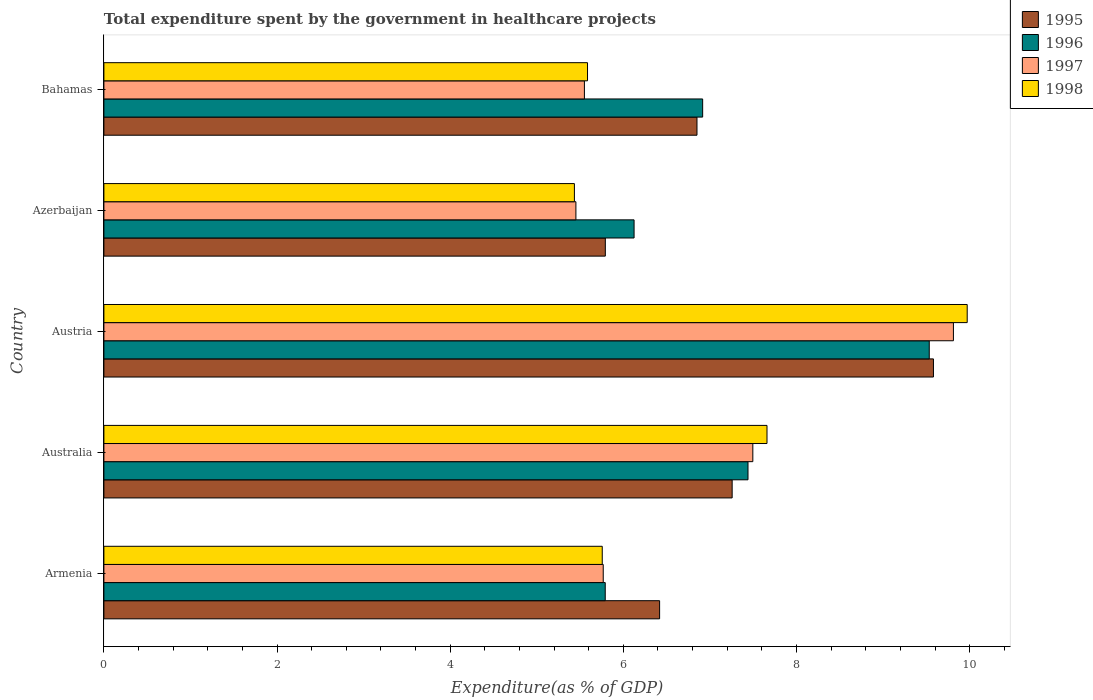Are the number of bars per tick equal to the number of legend labels?
Your response must be concise. Yes. How many bars are there on the 2nd tick from the bottom?
Your response must be concise. 4. What is the label of the 4th group of bars from the top?
Ensure brevity in your answer.  Australia. What is the total expenditure spent by the government in healthcare projects in 1998 in Azerbaijan?
Offer a very short reply. 5.43. Across all countries, what is the maximum total expenditure spent by the government in healthcare projects in 1997?
Offer a very short reply. 9.81. Across all countries, what is the minimum total expenditure spent by the government in healthcare projects in 1997?
Keep it short and to the point. 5.45. In which country was the total expenditure spent by the government in healthcare projects in 1997 maximum?
Your answer should be very brief. Austria. In which country was the total expenditure spent by the government in healthcare projects in 1998 minimum?
Keep it short and to the point. Azerbaijan. What is the total total expenditure spent by the government in healthcare projects in 1996 in the graph?
Ensure brevity in your answer.  35.8. What is the difference between the total expenditure spent by the government in healthcare projects in 1997 in Austria and that in Bahamas?
Your response must be concise. 4.26. What is the difference between the total expenditure spent by the government in healthcare projects in 1996 in Australia and the total expenditure spent by the government in healthcare projects in 1998 in Armenia?
Make the answer very short. 1.68. What is the average total expenditure spent by the government in healthcare projects in 1998 per country?
Your response must be concise. 6.88. What is the difference between the total expenditure spent by the government in healthcare projects in 1998 and total expenditure spent by the government in healthcare projects in 1995 in Austria?
Keep it short and to the point. 0.39. What is the ratio of the total expenditure spent by the government in healthcare projects in 1996 in Austria to that in Bahamas?
Make the answer very short. 1.38. What is the difference between the highest and the second highest total expenditure spent by the government in healthcare projects in 1995?
Ensure brevity in your answer.  2.33. What is the difference between the highest and the lowest total expenditure spent by the government in healthcare projects in 1996?
Offer a terse response. 3.74. In how many countries, is the total expenditure spent by the government in healthcare projects in 1996 greater than the average total expenditure spent by the government in healthcare projects in 1996 taken over all countries?
Ensure brevity in your answer.  2. Is the sum of the total expenditure spent by the government in healthcare projects in 1997 in Armenia and Bahamas greater than the maximum total expenditure spent by the government in healthcare projects in 1995 across all countries?
Your answer should be very brief. Yes. What does the 4th bar from the top in Australia represents?
Your answer should be compact. 1995. Is it the case that in every country, the sum of the total expenditure spent by the government in healthcare projects in 1995 and total expenditure spent by the government in healthcare projects in 1996 is greater than the total expenditure spent by the government in healthcare projects in 1997?
Your answer should be compact. Yes. How many bars are there?
Offer a very short reply. 20. Are the values on the major ticks of X-axis written in scientific E-notation?
Your answer should be compact. No. Does the graph contain any zero values?
Give a very brief answer. No. Does the graph contain grids?
Provide a succinct answer. No. What is the title of the graph?
Your answer should be very brief. Total expenditure spent by the government in healthcare projects. Does "1977" appear as one of the legend labels in the graph?
Ensure brevity in your answer.  No. What is the label or title of the X-axis?
Give a very brief answer. Expenditure(as % of GDP). What is the label or title of the Y-axis?
Make the answer very short. Country. What is the Expenditure(as % of GDP) in 1995 in Armenia?
Offer a very short reply. 6.42. What is the Expenditure(as % of GDP) in 1996 in Armenia?
Your answer should be compact. 5.79. What is the Expenditure(as % of GDP) of 1997 in Armenia?
Your answer should be compact. 5.77. What is the Expenditure(as % of GDP) in 1998 in Armenia?
Give a very brief answer. 5.76. What is the Expenditure(as % of GDP) of 1995 in Australia?
Offer a terse response. 7.26. What is the Expenditure(as % of GDP) of 1996 in Australia?
Provide a succinct answer. 7.44. What is the Expenditure(as % of GDP) in 1997 in Australia?
Offer a very short reply. 7.5. What is the Expenditure(as % of GDP) in 1998 in Australia?
Offer a very short reply. 7.66. What is the Expenditure(as % of GDP) in 1995 in Austria?
Keep it short and to the point. 9.58. What is the Expenditure(as % of GDP) of 1996 in Austria?
Give a very brief answer. 9.53. What is the Expenditure(as % of GDP) in 1997 in Austria?
Offer a very short reply. 9.81. What is the Expenditure(as % of GDP) of 1998 in Austria?
Your answer should be compact. 9.97. What is the Expenditure(as % of GDP) of 1995 in Azerbaijan?
Offer a terse response. 5.79. What is the Expenditure(as % of GDP) in 1996 in Azerbaijan?
Offer a very short reply. 6.12. What is the Expenditure(as % of GDP) of 1997 in Azerbaijan?
Your response must be concise. 5.45. What is the Expenditure(as % of GDP) of 1998 in Azerbaijan?
Ensure brevity in your answer.  5.43. What is the Expenditure(as % of GDP) in 1995 in Bahamas?
Offer a very short reply. 6.85. What is the Expenditure(as % of GDP) in 1996 in Bahamas?
Ensure brevity in your answer.  6.92. What is the Expenditure(as % of GDP) in 1997 in Bahamas?
Provide a succinct answer. 5.55. What is the Expenditure(as % of GDP) in 1998 in Bahamas?
Keep it short and to the point. 5.59. Across all countries, what is the maximum Expenditure(as % of GDP) in 1995?
Offer a very short reply. 9.58. Across all countries, what is the maximum Expenditure(as % of GDP) of 1996?
Provide a short and direct response. 9.53. Across all countries, what is the maximum Expenditure(as % of GDP) in 1997?
Provide a succinct answer. 9.81. Across all countries, what is the maximum Expenditure(as % of GDP) in 1998?
Your response must be concise. 9.97. Across all countries, what is the minimum Expenditure(as % of GDP) of 1995?
Provide a succinct answer. 5.79. Across all countries, what is the minimum Expenditure(as % of GDP) of 1996?
Make the answer very short. 5.79. Across all countries, what is the minimum Expenditure(as % of GDP) of 1997?
Keep it short and to the point. 5.45. Across all countries, what is the minimum Expenditure(as % of GDP) in 1998?
Provide a succinct answer. 5.43. What is the total Expenditure(as % of GDP) in 1995 in the graph?
Your answer should be very brief. 35.9. What is the total Expenditure(as % of GDP) in 1996 in the graph?
Keep it short and to the point. 35.8. What is the total Expenditure(as % of GDP) in 1997 in the graph?
Keep it short and to the point. 34.08. What is the total Expenditure(as % of GDP) in 1998 in the graph?
Your answer should be very brief. 34.41. What is the difference between the Expenditure(as % of GDP) of 1995 in Armenia and that in Australia?
Your answer should be compact. -0.84. What is the difference between the Expenditure(as % of GDP) in 1996 in Armenia and that in Australia?
Your answer should be compact. -1.65. What is the difference between the Expenditure(as % of GDP) in 1997 in Armenia and that in Australia?
Your response must be concise. -1.73. What is the difference between the Expenditure(as % of GDP) of 1998 in Armenia and that in Australia?
Ensure brevity in your answer.  -1.9. What is the difference between the Expenditure(as % of GDP) of 1995 in Armenia and that in Austria?
Keep it short and to the point. -3.16. What is the difference between the Expenditure(as % of GDP) of 1996 in Armenia and that in Austria?
Provide a short and direct response. -3.74. What is the difference between the Expenditure(as % of GDP) in 1997 in Armenia and that in Austria?
Give a very brief answer. -4.04. What is the difference between the Expenditure(as % of GDP) in 1998 in Armenia and that in Austria?
Offer a terse response. -4.22. What is the difference between the Expenditure(as % of GDP) in 1995 in Armenia and that in Azerbaijan?
Make the answer very short. 0.63. What is the difference between the Expenditure(as % of GDP) in 1996 in Armenia and that in Azerbaijan?
Make the answer very short. -0.33. What is the difference between the Expenditure(as % of GDP) in 1997 in Armenia and that in Azerbaijan?
Your response must be concise. 0.32. What is the difference between the Expenditure(as % of GDP) in 1998 in Armenia and that in Azerbaijan?
Offer a terse response. 0.32. What is the difference between the Expenditure(as % of GDP) of 1995 in Armenia and that in Bahamas?
Your response must be concise. -0.43. What is the difference between the Expenditure(as % of GDP) of 1996 in Armenia and that in Bahamas?
Your answer should be compact. -1.13. What is the difference between the Expenditure(as % of GDP) of 1997 in Armenia and that in Bahamas?
Keep it short and to the point. 0.22. What is the difference between the Expenditure(as % of GDP) of 1998 in Armenia and that in Bahamas?
Provide a short and direct response. 0.17. What is the difference between the Expenditure(as % of GDP) of 1995 in Australia and that in Austria?
Provide a short and direct response. -2.33. What is the difference between the Expenditure(as % of GDP) in 1996 in Australia and that in Austria?
Ensure brevity in your answer.  -2.09. What is the difference between the Expenditure(as % of GDP) in 1997 in Australia and that in Austria?
Provide a succinct answer. -2.32. What is the difference between the Expenditure(as % of GDP) of 1998 in Australia and that in Austria?
Your answer should be compact. -2.31. What is the difference between the Expenditure(as % of GDP) of 1995 in Australia and that in Azerbaijan?
Your response must be concise. 1.46. What is the difference between the Expenditure(as % of GDP) of 1996 in Australia and that in Azerbaijan?
Offer a very short reply. 1.32. What is the difference between the Expenditure(as % of GDP) in 1997 in Australia and that in Azerbaijan?
Offer a very short reply. 2.04. What is the difference between the Expenditure(as % of GDP) of 1998 in Australia and that in Azerbaijan?
Ensure brevity in your answer.  2.22. What is the difference between the Expenditure(as % of GDP) in 1995 in Australia and that in Bahamas?
Give a very brief answer. 0.41. What is the difference between the Expenditure(as % of GDP) of 1996 in Australia and that in Bahamas?
Your answer should be very brief. 0.52. What is the difference between the Expenditure(as % of GDP) in 1997 in Australia and that in Bahamas?
Your answer should be very brief. 1.95. What is the difference between the Expenditure(as % of GDP) in 1998 in Australia and that in Bahamas?
Offer a terse response. 2.07. What is the difference between the Expenditure(as % of GDP) in 1995 in Austria and that in Azerbaijan?
Keep it short and to the point. 3.79. What is the difference between the Expenditure(as % of GDP) of 1996 in Austria and that in Azerbaijan?
Offer a very short reply. 3.41. What is the difference between the Expenditure(as % of GDP) of 1997 in Austria and that in Azerbaijan?
Your response must be concise. 4.36. What is the difference between the Expenditure(as % of GDP) of 1998 in Austria and that in Azerbaijan?
Your answer should be compact. 4.54. What is the difference between the Expenditure(as % of GDP) in 1995 in Austria and that in Bahamas?
Offer a terse response. 2.73. What is the difference between the Expenditure(as % of GDP) of 1996 in Austria and that in Bahamas?
Provide a short and direct response. 2.62. What is the difference between the Expenditure(as % of GDP) in 1997 in Austria and that in Bahamas?
Your answer should be compact. 4.26. What is the difference between the Expenditure(as % of GDP) in 1998 in Austria and that in Bahamas?
Ensure brevity in your answer.  4.39. What is the difference between the Expenditure(as % of GDP) in 1995 in Azerbaijan and that in Bahamas?
Offer a very short reply. -1.06. What is the difference between the Expenditure(as % of GDP) of 1996 in Azerbaijan and that in Bahamas?
Your answer should be very brief. -0.79. What is the difference between the Expenditure(as % of GDP) in 1997 in Azerbaijan and that in Bahamas?
Your answer should be compact. -0.1. What is the difference between the Expenditure(as % of GDP) in 1998 in Azerbaijan and that in Bahamas?
Ensure brevity in your answer.  -0.15. What is the difference between the Expenditure(as % of GDP) in 1995 in Armenia and the Expenditure(as % of GDP) in 1996 in Australia?
Your answer should be compact. -1.02. What is the difference between the Expenditure(as % of GDP) in 1995 in Armenia and the Expenditure(as % of GDP) in 1997 in Australia?
Your answer should be compact. -1.08. What is the difference between the Expenditure(as % of GDP) in 1995 in Armenia and the Expenditure(as % of GDP) in 1998 in Australia?
Provide a succinct answer. -1.24. What is the difference between the Expenditure(as % of GDP) in 1996 in Armenia and the Expenditure(as % of GDP) in 1997 in Australia?
Make the answer very short. -1.7. What is the difference between the Expenditure(as % of GDP) in 1996 in Armenia and the Expenditure(as % of GDP) in 1998 in Australia?
Offer a terse response. -1.87. What is the difference between the Expenditure(as % of GDP) in 1997 in Armenia and the Expenditure(as % of GDP) in 1998 in Australia?
Ensure brevity in your answer.  -1.89. What is the difference between the Expenditure(as % of GDP) of 1995 in Armenia and the Expenditure(as % of GDP) of 1996 in Austria?
Offer a terse response. -3.11. What is the difference between the Expenditure(as % of GDP) in 1995 in Armenia and the Expenditure(as % of GDP) in 1997 in Austria?
Offer a terse response. -3.39. What is the difference between the Expenditure(as % of GDP) of 1995 in Armenia and the Expenditure(as % of GDP) of 1998 in Austria?
Provide a short and direct response. -3.55. What is the difference between the Expenditure(as % of GDP) in 1996 in Armenia and the Expenditure(as % of GDP) in 1997 in Austria?
Your answer should be compact. -4.02. What is the difference between the Expenditure(as % of GDP) in 1996 in Armenia and the Expenditure(as % of GDP) in 1998 in Austria?
Make the answer very short. -4.18. What is the difference between the Expenditure(as % of GDP) in 1997 in Armenia and the Expenditure(as % of GDP) in 1998 in Austria?
Your answer should be compact. -4.2. What is the difference between the Expenditure(as % of GDP) in 1995 in Armenia and the Expenditure(as % of GDP) in 1996 in Azerbaijan?
Make the answer very short. 0.29. What is the difference between the Expenditure(as % of GDP) of 1995 in Armenia and the Expenditure(as % of GDP) of 1997 in Azerbaijan?
Offer a very short reply. 0.97. What is the difference between the Expenditure(as % of GDP) in 1995 in Armenia and the Expenditure(as % of GDP) in 1998 in Azerbaijan?
Provide a short and direct response. 0.98. What is the difference between the Expenditure(as % of GDP) in 1996 in Armenia and the Expenditure(as % of GDP) in 1997 in Azerbaijan?
Give a very brief answer. 0.34. What is the difference between the Expenditure(as % of GDP) in 1996 in Armenia and the Expenditure(as % of GDP) in 1998 in Azerbaijan?
Ensure brevity in your answer.  0.36. What is the difference between the Expenditure(as % of GDP) of 1997 in Armenia and the Expenditure(as % of GDP) of 1998 in Azerbaijan?
Offer a very short reply. 0.33. What is the difference between the Expenditure(as % of GDP) in 1995 in Armenia and the Expenditure(as % of GDP) in 1996 in Bahamas?
Offer a very short reply. -0.5. What is the difference between the Expenditure(as % of GDP) in 1995 in Armenia and the Expenditure(as % of GDP) in 1997 in Bahamas?
Provide a succinct answer. 0.87. What is the difference between the Expenditure(as % of GDP) in 1995 in Armenia and the Expenditure(as % of GDP) in 1998 in Bahamas?
Your answer should be compact. 0.83. What is the difference between the Expenditure(as % of GDP) in 1996 in Armenia and the Expenditure(as % of GDP) in 1997 in Bahamas?
Provide a succinct answer. 0.24. What is the difference between the Expenditure(as % of GDP) of 1996 in Armenia and the Expenditure(as % of GDP) of 1998 in Bahamas?
Offer a terse response. 0.2. What is the difference between the Expenditure(as % of GDP) in 1997 in Armenia and the Expenditure(as % of GDP) in 1998 in Bahamas?
Make the answer very short. 0.18. What is the difference between the Expenditure(as % of GDP) of 1995 in Australia and the Expenditure(as % of GDP) of 1996 in Austria?
Your answer should be very brief. -2.28. What is the difference between the Expenditure(as % of GDP) of 1995 in Australia and the Expenditure(as % of GDP) of 1997 in Austria?
Offer a very short reply. -2.56. What is the difference between the Expenditure(as % of GDP) of 1995 in Australia and the Expenditure(as % of GDP) of 1998 in Austria?
Your answer should be compact. -2.71. What is the difference between the Expenditure(as % of GDP) of 1996 in Australia and the Expenditure(as % of GDP) of 1997 in Austria?
Provide a succinct answer. -2.37. What is the difference between the Expenditure(as % of GDP) of 1996 in Australia and the Expenditure(as % of GDP) of 1998 in Austria?
Keep it short and to the point. -2.53. What is the difference between the Expenditure(as % of GDP) in 1997 in Australia and the Expenditure(as % of GDP) in 1998 in Austria?
Offer a terse response. -2.48. What is the difference between the Expenditure(as % of GDP) in 1995 in Australia and the Expenditure(as % of GDP) in 1996 in Azerbaijan?
Make the answer very short. 1.13. What is the difference between the Expenditure(as % of GDP) of 1995 in Australia and the Expenditure(as % of GDP) of 1997 in Azerbaijan?
Your response must be concise. 1.8. What is the difference between the Expenditure(as % of GDP) of 1995 in Australia and the Expenditure(as % of GDP) of 1998 in Azerbaijan?
Provide a succinct answer. 1.82. What is the difference between the Expenditure(as % of GDP) in 1996 in Australia and the Expenditure(as % of GDP) in 1997 in Azerbaijan?
Your answer should be very brief. 1.99. What is the difference between the Expenditure(as % of GDP) of 1996 in Australia and the Expenditure(as % of GDP) of 1998 in Azerbaijan?
Provide a succinct answer. 2.01. What is the difference between the Expenditure(as % of GDP) in 1997 in Australia and the Expenditure(as % of GDP) in 1998 in Azerbaijan?
Provide a short and direct response. 2.06. What is the difference between the Expenditure(as % of GDP) of 1995 in Australia and the Expenditure(as % of GDP) of 1996 in Bahamas?
Provide a short and direct response. 0.34. What is the difference between the Expenditure(as % of GDP) in 1995 in Australia and the Expenditure(as % of GDP) in 1997 in Bahamas?
Keep it short and to the point. 1.71. What is the difference between the Expenditure(as % of GDP) of 1995 in Australia and the Expenditure(as % of GDP) of 1998 in Bahamas?
Provide a short and direct response. 1.67. What is the difference between the Expenditure(as % of GDP) of 1996 in Australia and the Expenditure(as % of GDP) of 1997 in Bahamas?
Make the answer very short. 1.89. What is the difference between the Expenditure(as % of GDP) of 1996 in Australia and the Expenditure(as % of GDP) of 1998 in Bahamas?
Your answer should be very brief. 1.85. What is the difference between the Expenditure(as % of GDP) of 1997 in Australia and the Expenditure(as % of GDP) of 1998 in Bahamas?
Your answer should be compact. 1.91. What is the difference between the Expenditure(as % of GDP) of 1995 in Austria and the Expenditure(as % of GDP) of 1996 in Azerbaijan?
Provide a succinct answer. 3.46. What is the difference between the Expenditure(as % of GDP) in 1995 in Austria and the Expenditure(as % of GDP) in 1997 in Azerbaijan?
Your response must be concise. 4.13. What is the difference between the Expenditure(as % of GDP) in 1995 in Austria and the Expenditure(as % of GDP) in 1998 in Azerbaijan?
Provide a short and direct response. 4.15. What is the difference between the Expenditure(as % of GDP) of 1996 in Austria and the Expenditure(as % of GDP) of 1997 in Azerbaijan?
Ensure brevity in your answer.  4.08. What is the difference between the Expenditure(as % of GDP) in 1996 in Austria and the Expenditure(as % of GDP) in 1998 in Azerbaijan?
Your response must be concise. 4.1. What is the difference between the Expenditure(as % of GDP) of 1997 in Austria and the Expenditure(as % of GDP) of 1998 in Azerbaijan?
Provide a short and direct response. 4.38. What is the difference between the Expenditure(as % of GDP) in 1995 in Austria and the Expenditure(as % of GDP) in 1996 in Bahamas?
Offer a terse response. 2.67. What is the difference between the Expenditure(as % of GDP) of 1995 in Austria and the Expenditure(as % of GDP) of 1997 in Bahamas?
Offer a very short reply. 4.03. What is the difference between the Expenditure(as % of GDP) of 1995 in Austria and the Expenditure(as % of GDP) of 1998 in Bahamas?
Provide a short and direct response. 4. What is the difference between the Expenditure(as % of GDP) of 1996 in Austria and the Expenditure(as % of GDP) of 1997 in Bahamas?
Ensure brevity in your answer.  3.98. What is the difference between the Expenditure(as % of GDP) of 1996 in Austria and the Expenditure(as % of GDP) of 1998 in Bahamas?
Offer a very short reply. 3.95. What is the difference between the Expenditure(as % of GDP) of 1997 in Austria and the Expenditure(as % of GDP) of 1998 in Bahamas?
Your answer should be very brief. 4.23. What is the difference between the Expenditure(as % of GDP) of 1995 in Azerbaijan and the Expenditure(as % of GDP) of 1996 in Bahamas?
Provide a short and direct response. -1.12. What is the difference between the Expenditure(as % of GDP) in 1995 in Azerbaijan and the Expenditure(as % of GDP) in 1997 in Bahamas?
Your response must be concise. 0.24. What is the difference between the Expenditure(as % of GDP) of 1995 in Azerbaijan and the Expenditure(as % of GDP) of 1998 in Bahamas?
Provide a succinct answer. 0.21. What is the difference between the Expenditure(as % of GDP) in 1996 in Azerbaijan and the Expenditure(as % of GDP) in 1997 in Bahamas?
Keep it short and to the point. 0.57. What is the difference between the Expenditure(as % of GDP) in 1996 in Azerbaijan and the Expenditure(as % of GDP) in 1998 in Bahamas?
Offer a terse response. 0.54. What is the difference between the Expenditure(as % of GDP) in 1997 in Azerbaijan and the Expenditure(as % of GDP) in 1998 in Bahamas?
Your answer should be very brief. -0.13. What is the average Expenditure(as % of GDP) in 1995 per country?
Your answer should be compact. 7.18. What is the average Expenditure(as % of GDP) of 1996 per country?
Provide a short and direct response. 7.16. What is the average Expenditure(as % of GDP) of 1997 per country?
Provide a succinct answer. 6.82. What is the average Expenditure(as % of GDP) of 1998 per country?
Ensure brevity in your answer.  6.88. What is the difference between the Expenditure(as % of GDP) in 1995 and Expenditure(as % of GDP) in 1996 in Armenia?
Your answer should be compact. 0.63. What is the difference between the Expenditure(as % of GDP) in 1995 and Expenditure(as % of GDP) in 1997 in Armenia?
Give a very brief answer. 0.65. What is the difference between the Expenditure(as % of GDP) of 1995 and Expenditure(as % of GDP) of 1998 in Armenia?
Give a very brief answer. 0.66. What is the difference between the Expenditure(as % of GDP) in 1996 and Expenditure(as % of GDP) in 1997 in Armenia?
Your response must be concise. 0.02. What is the difference between the Expenditure(as % of GDP) of 1996 and Expenditure(as % of GDP) of 1998 in Armenia?
Make the answer very short. 0.03. What is the difference between the Expenditure(as % of GDP) of 1997 and Expenditure(as % of GDP) of 1998 in Armenia?
Keep it short and to the point. 0.01. What is the difference between the Expenditure(as % of GDP) in 1995 and Expenditure(as % of GDP) in 1996 in Australia?
Offer a very short reply. -0.18. What is the difference between the Expenditure(as % of GDP) of 1995 and Expenditure(as % of GDP) of 1997 in Australia?
Keep it short and to the point. -0.24. What is the difference between the Expenditure(as % of GDP) of 1995 and Expenditure(as % of GDP) of 1998 in Australia?
Ensure brevity in your answer.  -0.4. What is the difference between the Expenditure(as % of GDP) in 1996 and Expenditure(as % of GDP) in 1997 in Australia?
Give a very brief answer. -0.06. What is the difference between the Expenditure(as % of GDP) in 1996 and Expenditure(as % of GDP) in 1998 in Australia?
Keep it short and to the point. -0.22. What is the difference between the Expenditure(as % of GDP) in 1997 and Expenditure(as % of GDP) in 1998 in Australia?
Provide a succinct answer. -0.16. What is the difference between the Expenditure(as % of GDP) in 1995 and Expenditure(as % of GDP) in 1996 in Austria?
Ensure brevity in your answer.  0.05. What is the difference between the Expenditure(as % of GDP) in 1995 and Expenditure(as % of GDP) in 1997 in Austria?
Keep it short and to the point. -0.23. What is the difference between the Expenditure(as % of GDP) of 1995 and Expenditure(as % of GDP) of 1998 in Austria?
Your answer should be compact. -0.39. What is the difference between the Expenditure(as % of GDP) of 1996 and Expenditure(as % of GDP) of 1997 in Austria?
Offer a terse response. -0.28. What is the difference between the Expenditure(as % of GDP) in 1996 and Expenditure(as % of GDP) in 1998 in Austria?
Make the answer very short. -0.44. What is the difference between the Expenditure(as % of GDP) of 1997 and Expenditure(as % of GDP) of 1998 in Austria?
Keep it short and to the point. -0.16. What is the difference between the Expenditure(as % of GDP) in 1995 and Expenditure(as % of GDP) in 1996 in Azerbaijan?
Give a very brief answer. -0.33. What is the difference between the Expenditure(as % of GDP) in 1995 and Expenditure(as % of GDP) in 1997 in Azerbaijan?
Provide a short and direct response. 0.34. What is the difference between the Expenditure(as % of GDP) of 1995 and Expenditure(as % of GDP) of 1998 in Azerbaijan?
Your answer should be very brief. 0.36. What is the difference between the Expenditure(as % of GDP) in 1996 and Expenditure(as % of GDP) in 1997 in Azerbaijan?
Provide a succinct answer. 0.67. What is the difference between the Expenditure(as % of GDP) in 1996 and Expenditure(as % of GDP) in 1998 in Azerbaijan?
Ensure brevity in your answer.  0.69. What is the difference between the Expenditure(as % of GDP) in 1997 and Expenditure(as % of GDP) in 1998 in Azerbaijan?
Offer a very short reply. 0.02. What is the difference between the Expenditure(as % of GDP) in 1995 and Expenditure(as % of GDP) in 1996 in Bahamas?
Make the answer very short. -0.07. What is the difference between the Expenditure(as % of GDP) of 1995 and Expenditure(as % of GDP) of 1997 in Bahamas?
Ensure brevity in your answer.  1.3. What is the difference between the Expenditure(as % of GDP) in 1995 and Expenditure(as % of GDP) in 1998 in Bahamas?
Your answer should be very brief. 1.26. What is the difference between the Expenditure(as % of GDP) in 1996 and Expenditure(as % of GDP) in 1997 in Bahamas?
Ensure brevity in your answer.  1.37. What is the difference between the Expenditure(as % of GDP) of 1996 and Expenditure(as % of GDP) of 1998 in Bahamas?
Provide a succinct answer. 1.33. What is the difference between the Expenditure(as % of GDP) in 1997 and Expenditure(as % of GDP) in 1998 in Bahamas?
Offer a terse response. -0.04. What is the ratio of the Expenditure(as % of GDP) in 1995 in Armenia to that in Australia?
Provide a succinct answer. 0.88. What is the ratio of the Expenditure(as % of GDP) in 1996 in Armenia to that in Australia?
Your response must be concise. 0.78. What is the ratio of the Expenditure(as % of GDP) in 1997 in Armenia to that in Australia?
Your answer should be compact. 0.77. What is the ratio of the Expenditure(as % of GDP) in 1998 in Armenia to that in Australia?
Make the answer very short. 0.75. What is the ratio of the Expenditure(as % of GDP) in 1995 in Armenia to that in Austria?
Make the answer very short. 0.67. What is the ratio of the Expenditure(as % of GDP) of 1996 in Armenia to that in Austria?
Provide a short and direct response. 0.61. What is the ratio of the Expenditure(as % of GDP) of 1997 in Armenia to that in Austria?
Offer a very short reply. 0.59. What is the ratio of the Expenditure(as % of GDP) in 1998 in Armenia to that in Austria?
Your response must be concise. 0.58. What is the ratio of the Expenditure(as % of GDP) of 1995 in Armenia to that in Azerbaijan?
Offer a very short reply. 1.11. What is the ratio of the Expenditure(as % of GDP) in 1996 in Armenia to that in Azerbaijan?
Offer a terse response. 0.95. What is the ratio of the Expenditure(as % of GDP) in 1997 in Armenia to that in Azerbaijan?
Your response must be concise. 1.06. What is the ratio of the Expenditure(as % of GDP) in 1998 in Armenia to that in Azerbaijan?
Provide a short and direct response. 1.06. What is the ratio of the Expenditure(as % of GDP) of 1995 in Armenia to that in Bahamas?
Your answer should be compact. 0.94. What is the ratio of the Expenditure(as % of GDP) in 1996 in Armenia to that in Bahamas?
Keep it short and to the point. 0.84. What is the ratio of the Expenditure(as % of GDP) of 1997 in Armenia to that in Bahamas?
Your answer should be very brief. 1.04. What is the ratio of the Expenditure(as % of GDP) in 1998 in Armenia to that in Bahamas?
Keep it short and to the point. 1.03. What is the ratio of the Expenditure(as % of GDP) of 1995 in Australia to that in Austria?
Your response must be concise. 0.76. What is the ratio of the Expenditure(as % of GDP) in 1996 in Australia to that in Austria?
Provide a short and direct response. 0.78. What is the ratio of the Expenditure(as % of GDP) in 1997 in Australia to that in Austria?
Ensure brevity in your answer.  0.76. What is the ratio of the Expenditure(as % of GDP) of 1998 in Australia to that in Austria?
Make the answer very short. 0.77. What is the ratio of the Expenditure(as % of GDP) in 1995 in Australia to that in Azerbaijan?
Provide a short and direct response. 1.25. What is the ratio of the Expenditure(as % of GDP) of 1996 in Australia to that in Azerbaijan?
Offer a very short reply. 1.21. What is the ratio of the Expenditure(as % of GDP) of 1997 in Australia to that in Azerbaijan?
Provide a succinct answer. 1.37. What is the ratio of the Expenditure(as % of GDP) of 1998 in Australia to that in Azerbaijan?
Make the answer very short. 1.41. What is the ratio of the Expenditure(as % of GDP) of 1995 in Australia to that in Bahamas?
Give a very brief answer. 1.06. What is the ratio of the Expenditure(as % of GDP) of 1996 in Australia to that in Bahamas?
Make the answer very short. 1.08. What is the ratio of the Expenditure(as % of GDP) of 1997 in Australia to that in Bahamas?
Keep it short and to the point. 1.35. What is the ratio of the Expenditure(as % of GDP) in 1998 in Australia to that in Bahamas?
Your answer should be compact. 1.37. What is the ratio of the Expenditure(as % of GDP) in 1995 in Austria to that in Azerbaijan?
Make the answer very short. 1.65. What is the ratio of the Expenditure(as % of GDP) of 1996 in Austria to that in Azerbaijan?
Ensure brevity in your answer.  1.56. What is the ratio of the Expenditure(as % of GDP) in 1997 in Austria to that in Azerbaijan?
Ensure brevity in your answer.  1.8. What is the ratio of the Expenditure(as % of GDP) in 1998 in Austria to that in Azerbaijan?
Provide a succinct answer. 1.83. What is the ratio of the Expenditure(as % of GDP) of 1995 in Austria to that in Bahamas?
Your answer should be compact. 1.4. What is the ratio of the Expenditure(as % of GDP) of 1996 in Austria to that in Bahamas?
Offer a very short reply. 1.38. What is the ratio of the Expenditure(as % of GDP) of 1997 in Austria to that in Bahamas?
Your answer should be compact. 1.77. What is the ratio of the Expenditure(as % of GDP) in 1998 in Austria to that in Bahamas?
Your response must be concise. 1.79. What is the ratio of the Expenditure(as % of GDP) of 1995 in Azerbaijan to that in Bahamas?
Give a very brief answer. 0.85. What is the ratio of the Expenditure(as % of GDP) in 1996 in Azerbaijan to that in Bahamas?
Offer a terse response. 0.89. What is the ratio of the Expenditure(as % of GDP) of 1997 in Azerbaijan to that in Bahamas?
Give a very brief answer. 0.98. What is the ratio of the Expenditure(as % of GDP) of 1998 in Azerbaijan to that in Bahamas?
Offer a very short reply. 0.97. What is the difference between the highest and the second highest Expenditure(as % of GDP) of 1995?
Make the answer very short. 2.33. What is the difference between the highest and the second highest Expenditure(as % of GDP) in 1996?
Make the answer very short. 2.09. What is the difference between the highest and the second highest Expenditure(as % of GDP) in 1997?
Make the answer very short. 2.32. What is the difference between the highest and the second highest Expenditure(as % of GDP) of 1998?
Offer a very short reply. 2.31. What is the difference between the highest and the lowest Expenditure(as % of GDP) in 1995?
Your answer should be compact. 3.79. What is the difference between the highest and the lowest Expenditure(as % of GDP) of 1996?
Make the answer very short. 3.74. What is the difference between the highest and the lowest Expenditure(as % of GDP) in 1997?
Provide a succinct answer. 4.36. What is the difference between the highest and the lowest Expenditure(as % of GDP) in 1998?
Your response must be concise. 4.54. 